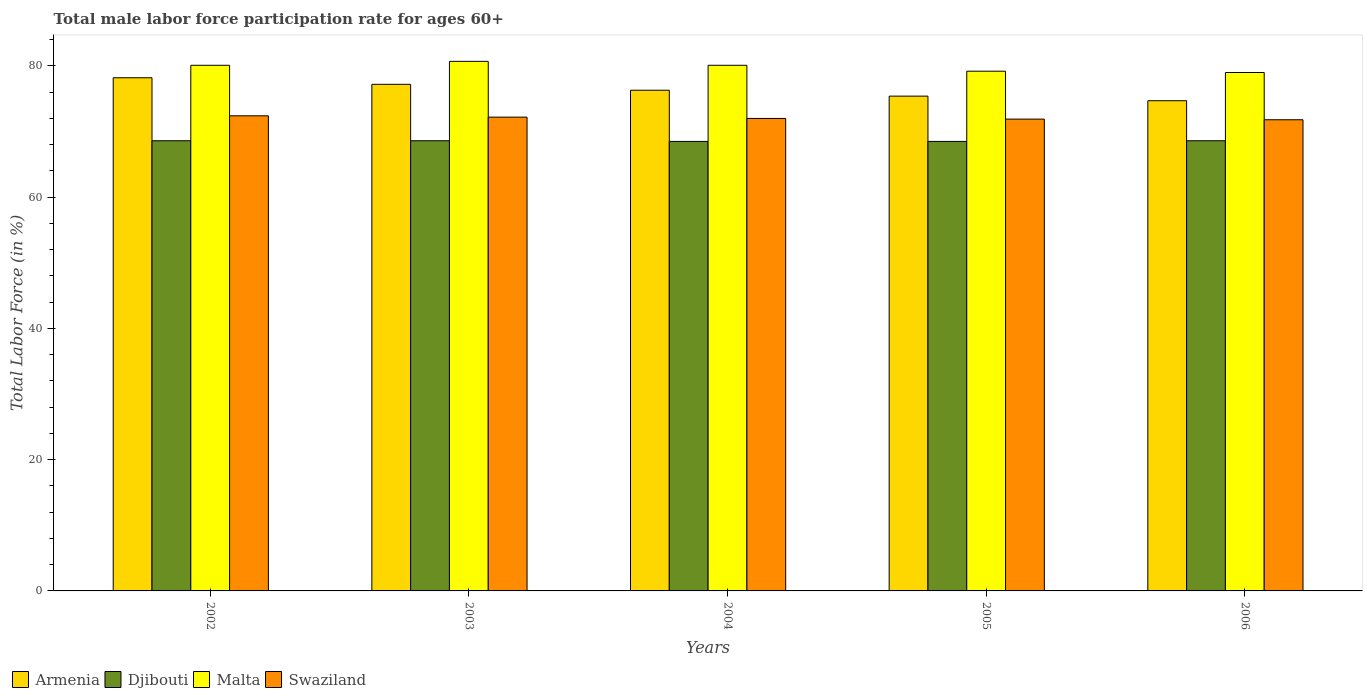Are the number of bars per tick equal to the number of legend labels?
Your answer should be very brief. Yes. How many bars are there on the 1st tick from the left?
Keep it short and to the point. 4. What is the label of the 3rd group of bars from the left?
Ensure brevity in your answer.  2004. What is the male labor force participation rate in Armenia in 2004?
Provide a short and direct response. 76.3. Across all years, what is the maximum male labor force participation rate in Armenia?
Offer a very short reply. 78.2. Across all years, what is the minimum male labor force participation rate in Djibouti?
Offer a terse response. 68.5. In which year was the male labor force participation rate in Malta maximum?
Provide a succinct answer. 2003. What is the total male labor force participation rate in Armenia in the graph?
Provide a short and direct response. 381.8. What is the difference between the male labor force participation rate in Armenia in 2003 and that in 2004?
Offer a very short reply. 0.9. What is the difference between the male labor force participation rate in Swaziland in 2003 and the male labor force participation rate in Armenia in 2002?
Ensure brevity in your answer.  -6. What is the average male labor force participation rate in Swaziland per year?
Make the answer very short. 72.06. In the year 2005, what is the difference between the male labor force participation rate in Armenia and male labor force participation rate in Malta?
Keep it short and to the point. -3.8. In how many years, is the male labor force participation rate in Swaziland greater than 36 %?
Offer a terse response. 5. What is the ratio of the male labor force participation rate in Malta in 2004 to that in 2006?
Your response must be concise. 1.01. Is the male labor force participation rate in Swaziland in 2003 less than that in 2006?
Your answer should be very brief. No. What is the difference between the highest and the second highest male labor force participation rate in Swaziland?
Your answer should be compact. 0.2. What is the difference between the highest and the lowest male labor force participation rate in Djibouti?
Make the answer very short. 0.1. In how many years, is the male labor force participation rate in Armenia greater than the average male labor force participation rate in Armenia taken over all years?
Give a very brief answer. 2. Is it the case that in every year, the sum of the male labor force participation rate in Armenia and male labor force participation rate in Djibouti is greater than the sum of male labor force participation rate in Malta and male labor force participation rate in Swaziland?
Make the answer very short. No. What does the 2nd bar from the left in 2004 represents?
Your response must be concise. Djibouti. What does the 3rd bar from the right in 2003 represents?
Offer a very short reply. Djibouti. Is it the case that in every year, the sum of the male labor force participation rate in Djibouti and male labor force participation rate in Malta is greater than the male labor force participation rate in Armenia?
Provide a succinct answer. Yes. How many years are there in the graph?
Offer a terse response. 5. What is the difference between two consecutive major ticks on the Y-axis?
Your response must be concise. 20. Are the values on the major ticks of Y-axis written in scientific E-notation?
Make the answer very short. No. Does the graph contain any zero values?
Ensure brevity in your answer.  No. How many legend labels are there?
Offer a terse response. 4. What is the title of the graph?
Your answer should be compact. Total male labor force participation rate for ages 60+. Does "Fiji" appear as one of the legend labels in the graph?
Your answer should be very brief. No. What is the Total Labor Force (in %) of Armenia in 2002?
Provide a short and direct response. 78.2. What is the Total Labor Force (in %) of Djibouti in 2002?
Provide a short and direct response. 68.6. What is the Total Labor Force (in %) in Malta in 2002?
Your answer should be compact. 80.1. What is the Total Labor Force (in %) of Swaziland in 2002?
Your answer should be very brief. 72.4. What is the Total Labor Force (in %) of Armenia in 2003?
Your response must be concise. 77.2. What is the Total Labor Force (in %) in Djibouti in 2003?
Your answer should be very brief. 68.6. What is the Total Labor Force (in %) of Malta in 2003?
Provide a succinct answer. 80.7. What is the Total Labor Force (in %) in Swaziland in 2003?
Your answer should be compact. 72.2. What is the Total Labor Force (in %) in Armenia in 2004?
Your answer should be compact. 76.3. What is the Total Labor Force (in %) of Djibouti in 2004?
Give a very brief answer. 68.5. What is the Total Labor Force (in %) of Malta in 2004?
Make the answer very short. 80.1. What is the Total Labor Force (in %) in Armenia in 2005?
Offer a very short reply. 75.4. What is the Total Labor Force (in %) of Djibouti in 2005?
Provide a succinct answer. 68.5. What is the Total Labor Force (in %) of Malta in 2005?
Provide a short and direct response. 79.2. What is the Total Labor Force (in %) of Swaziland in 2005?
Your answer should be compact. 71.9. What is the Total Labor Force (in %) in Armenia in 2006?
Offer a terse response. 74.7. What is the Total Labor Force (in %) in Djibouti in 2006?
Offer a terse response. 68.6. What is the Total Labor Force (in %) in Malta in 2006?
Make the answer very short. 79. What is the Total Labor Force (in %) in Swaziland in 2006?
Ensure brevity in your answer.  71.8. Across all years, what is the maximum Total Labor Force (in %) in Armenia?
Give a very brief answer. 78.2. Across all years, what is the maximum Total Labor Force (in %) of Djibouti?
Make the answer very short. 68.6. Across all years, what is the maximum Total Labor Force (in %) of Malta?
Offer a very short reply. 80.7. Across all years, what is the maximum Total Labor Force (in %) of Swaziland?
Give a very brief answer. 72.4. Across all years, what is the minimum Total Labor Force (in %) in Armenia?
Your answer should be very brief. 74.7. Across all years, what is the minimum Total Labor Force (in %) of Djibouti?
Give a very brief answer. 68.5. Across all years, what is the minimum Total Labor Force (in %) in Malta?
Ensure brevity in your answer.  79. Across all years, what is the minimum Total Labor Force (in %) of Swaziland?
Offer a very short reply. 71.8. What is the total Total Labor Force (in %) of Armenia in the graph?
Provide a succinct answer. 381.8. What is the total Total Labor Force (in %) of Djibouti in the graph?
Offer a very short reply. 342.8. What is the total Total Labor Force (in %) in Malta in the graph?
Your response must be concise. 399.1. What is the total Total Labor Force (in %) in Swaziland in the graph?
Your response must be concise. 360.3. What is the difference between the Total Labor Force (in %) in Malta in 2002 and that in 2003?
Your response must be concise. -0.6. What is the difference between the Total Labor Force (in %) in Armenia in 2002 and that in 2004?
Provide a succinct answer. 1.9. What is the difference between the Total Labor Force (in %) of Djibouti in 2002 and that in 2004?
Provide a short and direct response. 0.1. What is the difference between the Total Labor Force (in %) of Malta in 2002 and that in 2004?
Make the answer very short. 0. What is the difference between the Total Labor Force (in %) of Swaziland in 2002 and that in 2004?
Offer a very short reply. 0.4. What is the difference between the Total Labor Force (in %) of Djibouti in 2002 and that in 2005?
Offer a terse response. 0.1. What is the difference between the Total Labor Force (in %) in Swaziland in 2002 and that in 2005?
Keep it short and to the point. 0.5. What is the difference between the Total Labor Force (in %) of Malta in 2002 and that in 2006?
Your response must be concise. 1.1. What is the difference between the Total Labor Force (in %) in Swaziland in 2002 and that in 2006?
Your response must be concise. 0.6. What is the difference between the Total Labor Force (in %) of Armenia in 2003 and that in 2004?
Offer a terse response. 0.9. What is the difference between the Total Labor Force (in %) in Malta in 2003 and that in 2004?
Give a very brief answer. 0.6. What is the difference between the Total Labor Force (in %) of Swaziland in 2003 and that in 2004?
Your answer should be compact. 0.2. What is the difference between the Total Labor Force (in %) of Armenia in 2003 and that in 2005?
Make the answer very short. 1.8. What is the difference between the Total Labor Force (in %) of Djibouti in 2003 and that in 2005?
Your answer should be compact. 0.1. What is the difference between the Total Labor Force (in %) in Malta in 2003 and that in 2005?
Keep it short and to the point. 1.5. What is the difference between the Total Labor Force (in %) of Djibouti in 2003 and that in 2006?
Your answer should be compact. 0. What is the difference between the Total Labor Force (in %) of Djibouti in 2004 and that in 2005?
Keep it short and to the point. 0. What is the difference between the Total Labor Force (in %) in Malta in 2004 and that in 2005?
Give a very brief answer. 0.9. What is the difference between the Total Labor Force (in %) of Swaziland in 2004 and that in 2005?
Provide a succinct answer. 0.1. What is the difference between the Total Labor Force (in %) of Armenia in 2004 and that in 2006?
Your answer should be very brief. 1.6. What is the difference between the Total Labor Force (in %) of Malta in 2004 and that in 2006?
Keep it short and to the point. 1.1. What is the difference between the Total Labor Force (in %) of Malta in 2005 and that in 2006?
Ensure brevity in your answer.  0.2. What is the difference between the Total Labor Force (in %) in Swaziland in 2005 and that in 2006?
Offer a very short reply. 0.1. What is the difference between the Total Labor Force (in %) of Armenia in 2002 and the Total Labor Force (in %) of Djibouti in 2003?
Provide a short and direct response. 9.6. What is the difference between the Total Labor Force (in %) of Armenia in 2002 and the Total Labor Force (in %) of Malta in 2003?
Provide a succinct answer. -2.5. What is the difference between the Total Labor Force (in %) of Djibouti in 2002 and the Total Labor Force (in %) of Malta in 2003?
Your answer should be compact. -12.1. What is the difference between the Total Labor Force (in %) in Malta in 2002 and the Total Labor Force (in %) in Swaziland in 2003?
Your answer should be very brief. 7.9. What is the difference between the Total Labor Force (in %) in Armenia in 2002 and the Total Labor Force (in %) in Swaziland in 2004?
Your answer should be compact. 6.2. What is the difference between the Total Labor Force (in %) in Armenia in 2002 and the Total Labor Force (in %) in Djibouti in 2005?
Provide a short and direct response. 9.7. What is the difference between the Total Labor Force (in %) in Djibouti in 2002 and the Total Labor Force (in %) in Swaziland in 2005?
Give a very brief answer. -3.3. What is the difference between the Total Labor Force (in %) in Malta in 2002 and the Total Labor Force (in %) in Swaziland in 2005?
Provide a succinct answer. 8.2. What is the difference between the Total Labor Force (in %) of Armenia in 2002 and the Total Labor Force (in %) of Swaziland in 2006?
Provide a short and direct response. 6.4. What is the difference between the Total Labor Force (in %) in Djibouti in 2002 and the Total Labor Force (in %) in Malta in 2006?
Offer a terse response. -10.4. What is the difference between the Total Labor Force (in %) in Djibouti in 2002 and the Total Labor Force (in %) in Swaziland in 2006?
Provide a succinct answer. -3.2. What is the difference between the Total Labor Force (in %) in Armenia in 2003 and the Total Labor Force (in %) in Djibouti in 2004?
Your answer should be very brief. 8.7. What is the difference between the Total Labor Force (in %) of Djibouti in 2003 and the Total Labor Force (in %) of Malta in 2004?
Offer a very short reply. -11.5. What is the difference between the Total Labor Force (in %) in Djibouti in 2003 and the Total Labor Force (in %) in Swaziland in 2004?
Offer a terse response. -3.4. What is the difference between the Total Labor Force (in %) of Malta in 2003 and the Total Labor Force (in %) of Swaziland in 2004?
Your answer should be very brief. 8.7. What is the difference between the Total Labor Force (in %) in Djibouti in 2003 and the Total Labor Force (in %) in Malta in 2005?
Offer a terse response. -10.6. What is the difference between the Total Labor Force (in %) of Armenia in 2003 and the Total Labor Force (in %) of Djibouti in 2006?
Provide a succinct answer. 8.6. What is the difference between the Total Labor Force (in %) in Armenia in 2003 and the Total Labor Force (in %) in Malta in 2006?
Offer a very short reply. -1.8. What is the difference between the Total Labor Force (in %) of Djibouti in 2003 and the Total Labor Force (in %) of Malta in 2006?
Make the answer very short. -10.4. What is the difference between the Total Labor Force (in %) in Djibouti in 2003 and the Total Labor Force (in %) in Swaziland in 2006?
Provide a succinct answer. -3.2. What is the difference between the Total Labor Force (in %) of Armenia in 2004 and the Total Labor Force (in %) of Djibouti in 2005?
Keep it short and to the point. 7.8. What is the difference between the Total Labor Force (in %) of Djibouti in 2004 and the Total Labor Force (in %) of Swaziland in 2005?
Make the answer very short. -3.4. What is the difference between the Total Labor Force (in %) of Malta in 2004 and the Total Labor Force (in %) of Swaziland in 2005?
Provide a succinct answer. 8.2. What is the difference between the Total Labor Force (in %) in Armenia in 2004 and the Total Labor Force (in %) in Swaziland in 2006?
Provide a succinct answer. 4.5. What is the difference between the Total Labor Force (in %) of Malta in 2004 and the Total Labor Force (in %) of Swaziland in 2006?
Your answer should be compact. 8.3. What is the difference between the Total Labor Force (in %) in Djibouti in 2005 and the Total Labor Force (in %) in Swaziland in 2006?
Your response must be concise. -3.3. What is the difference between the Total Labor Force (in %) of Malta in 2005 and the Total Labor Force (in %) of Swaziland in 2006?
Offer a very short reply. 7.4. What is the average Total Labor Force (in %) in Armenia per year?
Give a very brief answer. 76.36. What is the average Total Labor Force (in %) in Djibouti per year?
Provide a short and direct response. 68.56. What is the average Total Labor Force (in %) in Malta per year?
Provide a succinct answer. 79.82. What is the average Total Labor Force (in %) of Swaziland per year?
Keep it short and to the point. 72.06. In the year 2002, what is the difference between the Total Labor Force (in %) in Armenia and Total Labor Force (in %) in Malta?
Provide a succinct answer. -1.9. In the year 2002, what is the difference between the Total Labor Force (in %) of Djibouti and Total Labor Force (in %) of Swaziland?
Provide a succinct answer. -3.8. In the year 2002, what is the difference between the Total Labor Force (in %) of Malta and Total Labor Force (in %) of Swaziland?
Your response must be concise. 7.7. In the year 2003, what is the difference between the Total Labor Force (in %) in Armenia and Total Labor Force (in %) in Malta?
Your response must be concise. -3.5. In the year 2003, what is the difference between the Total Labor Force (in %) of Armenia and Total Labor Force (in %) of Swaziland?
Ensure brevity in your answer.  5. In the year 2003, what is the difference between the Total Labor Force (in %) of Djibouti and Total Labor Force (in %) of Swaziland?
Give a very brief answer. -3.6. In the year 2003, what is the difference between the Total Labor Force (in %) of Malta and Total Labor Force (in %) of Swaziland?
Your answer should be compact. 8.5. In the year 2004, what is the difference between the Total Labor Force (in %) of Djibouti and Total Labor Force (in %) of Swaziland?
Provide a short and direct response. -3.5. In the year 2004, what is the difference between the Total Labor Force (in %) of Malta and Total Labor Force (in %) of Swaziland?
Your answer should be very brief. 8.1. In the year 2005, what is the difference between the Total Labor Force (in %) of Armenia and Total Labor Force (in %) of Malta?
Offer a very short reply. -3.8. In the year 2005, what is the difference between the Total Labor Force (in %) in Armenia and Total Labor Force (in %) in Swaziland?
Provide a succinct answer. 3.5. In the year 2005, what is the difference between the Total Labor Force (in %) of Djibouti and Total Labor Force (in %) of Malta?
Your answer should be very brief. -10.7. In the year 2005, what is the difference between the Total Labor Force (in %) of Malta and Total Labor Force (in %) of Swaziland?
Keep it short and to the point. 7.3. In the year 2006, what is the difference between the Total Labor Force (in %) of Armenia and Total Labor Force (in %) of Swaziland?
Ensure brevity in your answer.  2.9. In the year 2006, what is the difference between the Total Labor Force (in %) of Djibouti and Total Labor Force (in %) of Malta?
Ensure brevity in your answer.  -10.4. In the year 2006, what is the difference between the Total Labor Force (in %) of Malta and Total Labor Force (in %) of Swaziland?
Keep it short and to the point. 7.2. What is the ratio of the Total Labor Force (in %) in Armenia in 2002 to that in 2003?
Offer a very short reply. 1.01. What is the ratio of the Total Labor Force (in %) of Swaziland in 2002 to that in 2003?
Provide a succinct answer. 1. What is the ratio of the Total Labor Force (in %) in Armenia in 2002 to that in 2004?
Make the answer very short. 1.02. What is the ratio of the Total Labor Force (in %) of Malta in 2002 to that in 2004?
Provide a succinct answer. 1. What is the ratio of the Total Labor Force (in %) of Swaziland in 2002 to that in 2004?
Make the answer very short. 1.01. What is the ratio of the Total Labor Force (in %) in Armenia in 2002 to that in 2005?
Your answer should be very brief. 1.04. What is the ratio of the Total Labor Force (in %) of Djibouti in 2002 to that in 2005?
Your response must be concise. 1. What is the ratio of the Total Labor Force (in %) of Malta in 2002 to that in 2005?
Keep it short and to the point. 1.01. What is the ratio of the Total Labor Force (in %) in Swaziland in 2002 to that in 2005?
Keep it short and to the point. 1.01. What is the ratio of the Total Labor Force (in %) of Armenia in 2002 to that in 2006?
Provide a short and direct response. 1.05. What is the ratio of the Total Labor Force (in %) in Malta in 2002 to that in 2006?
Give a very brief answer. 1.01. What is the ratio of the Total Labor Force (in %) of Swaziland in 2002 to that in 2006?
Provide a short and direct response. 1.01. What is the ratio of the Total Labor Force (in %) of Armenia in 2003 to that in 2004?
Your answer should be very brief. 1.01. What is the ratio of the Total Labor Force (in %) of Djibouti in 2003 to that in 2004?
Offer a terse response. 1. What is the ratio of the Total Labor Force (in %) in Malta in 2003 to that in 2004?
Offer a terse response. 1.01. What is the ratio of the Total Labor Force (in %) of Swaziland in 2003 to that in 2004?
Provide a short and direct response. 1. What is the ratio of the Total Labor Force (in %) in Armenia in 2003 to that in 2005?
Offer a terse response. 1.02. What is the ratio of the Total Labor Force (in %) of Djibouti in 2003 to that in 2005?
Your answer should be very brief. 1. What is the ratio of the Total Labor Force (in %) of Malta in 2003 to that in 2005?
Offer a terse response. 1.02. What is the ratio of the Total Labor Force (in %) of Swaziland in 2003 to that in 2005?
Provide a succinct answer. 1. What is the ratio of the Total Labor Force (in %) in Armenia in 2003 to that in 2006?
Ensure brevity in your answer.  1.03. What is the ratio of the Total Labor Force (in %) of Djibouti in 2003 to that in 2006?
Your answer should be very brief. 1. What is the ratio of the Total Labor Force (in %) of Malta in 2003 to that in 2006?
Give a very brief answer. 1.02. What is the ratio of the Total Labor Force (in %) in Swaziland in 2003 to that in 2006?
Ensure brevity in your answer.  1.01. What is the ratio of the Total Labor Force (in %) of Armenia in 2004 to that in 2005?
Ensure brevity in your answer.  1.01. What is the ratio of the Total Labor Force (in %) of Djibouti in 2004 to that in 2005?
Offer a very short reply. 1. What is the ratio of the Total Labor Force (in %) of Malta in 2004 to that in 2005?
Offer a very short reply. 1.01. What is the ratio of the Total Labor Force (in %) in Armenia in 2004 to that in 2006?
Ensure brevity in your answer.  1.02. What is the ratio of the Total Labor Force (in %) of Djibouti in 2004 to that in 2006?
Give a very brief answer. 1. What is the ratio of the Total Labor Force (in %) of Malta in 2004 to that in 2006?
Your response must be concise. 1.01. What is the ratio of the Total Labor Force (in %) of Swaziland in 2004 to that in 2006?
Your answer should be very brief. 1. What is the ratio of the Total Labor Force (in %) of Armenia in 2005 to that in 2006?
Provide a short and direct response. 1.01. What is the ratio of the Total Labor Force (in %) of Djibouti in 2005 to that in 2006?
Your answer should be compact. 1. What is the difference between the highest and the second highest Total Labor Force (in %) in Armenia?
Offer a terse response. 1. What is the difference between the highest and the second highest Total Labor Force (in %) of Djibouti?
Give a very brief answer. 0. What is the difference between the highest and the second highest Total Labor Force (in %) of Malta?
Keep it short and to the point. 0.6. What is the difference between the highest and the lowest Total Labor Force (in %) of Malta?
Your answer should be compact. 1.7. What is the difference between the highest and the lowest Total Labor Force (in %) of Swaziland?
Offer a very short reply. 0.6. 